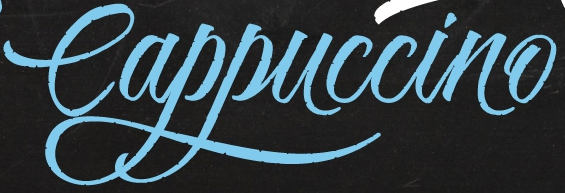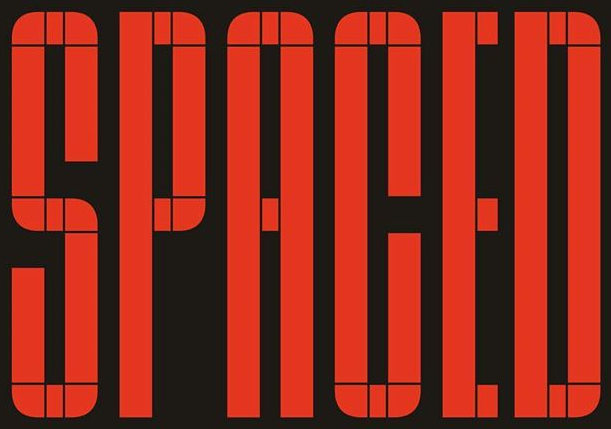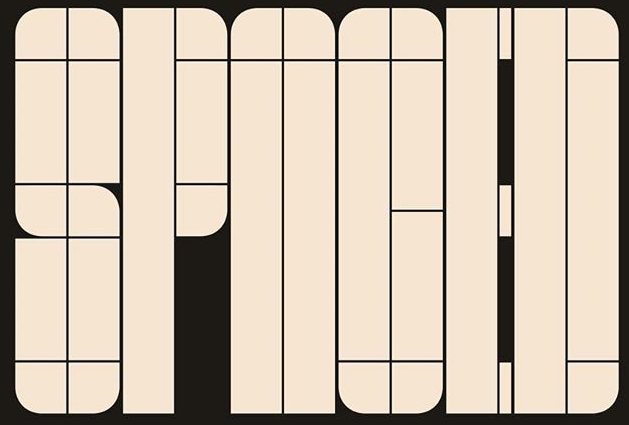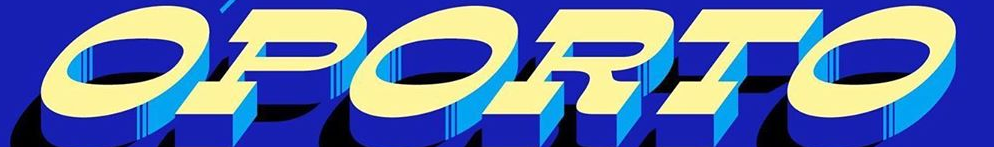What words are shown in these images in order, separated by a semicolon? Cappuccino; SPACED; SPNOED; OPORTO 